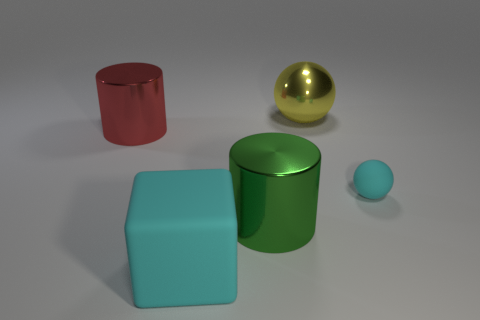Are there any other things that are the same size as the cyan rubber ball?
Ensure brevity in your answer.  No. Is there any other thing that is the same shape as the big cyan matte object?
Offer a terse response. No. There is a yellow object; does it have the same size as the sphere in front of the red metal cylinder?
Offer a terse response. No. There is a shiny cylinder that is right of the cyan object on the left side of the cyan thing to the right of the yellow thing; what is its size?
Give a very brief answer. Large. Is there a big green matte thing?
Offer a terse response. No. What number of rubber spheres are the same color as the big matte object?
Offer a terse response. 1. How many things are either small rubber objects right of the big yellow metal sphere or things to the right of the big red cylinder?
Provide a succinct answer. 4. What number of large cylinders are to the right of the matte object that is on the left side of the big metal ball?
Provide a short and direct response. 1. There is a ball that is made of the same material as the green object; what color is it?
Ensure brevity in your answer.  Yellow. Is there a cyan thing of the same size as the green shiny thing?
Provide a short and direct response. Yes. 